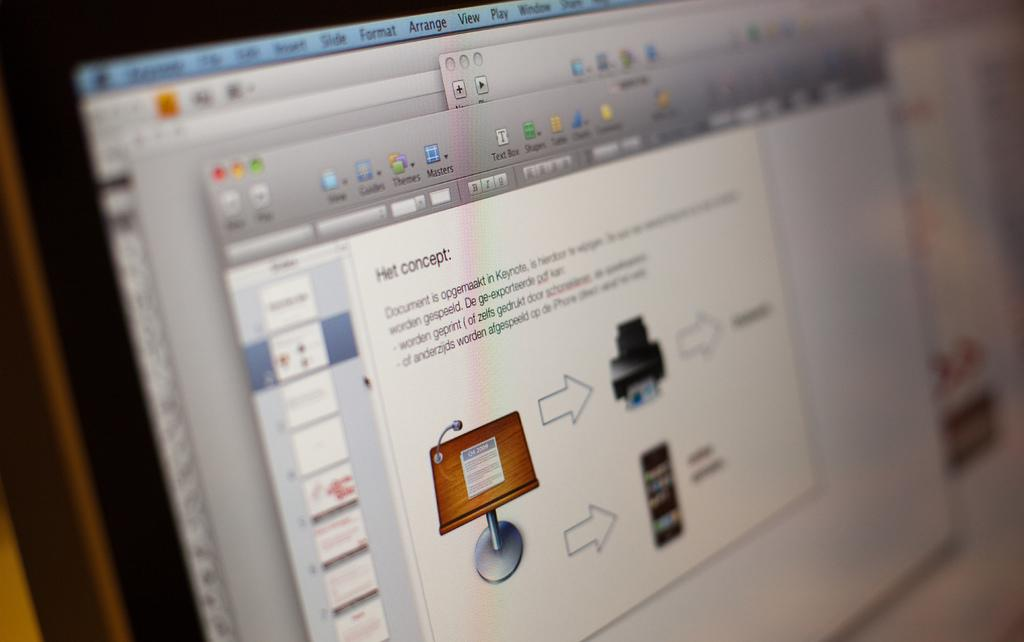Provide a one-sentence caption for the provided image. A computer screen has a slide maker open and talking about the Het concept. 